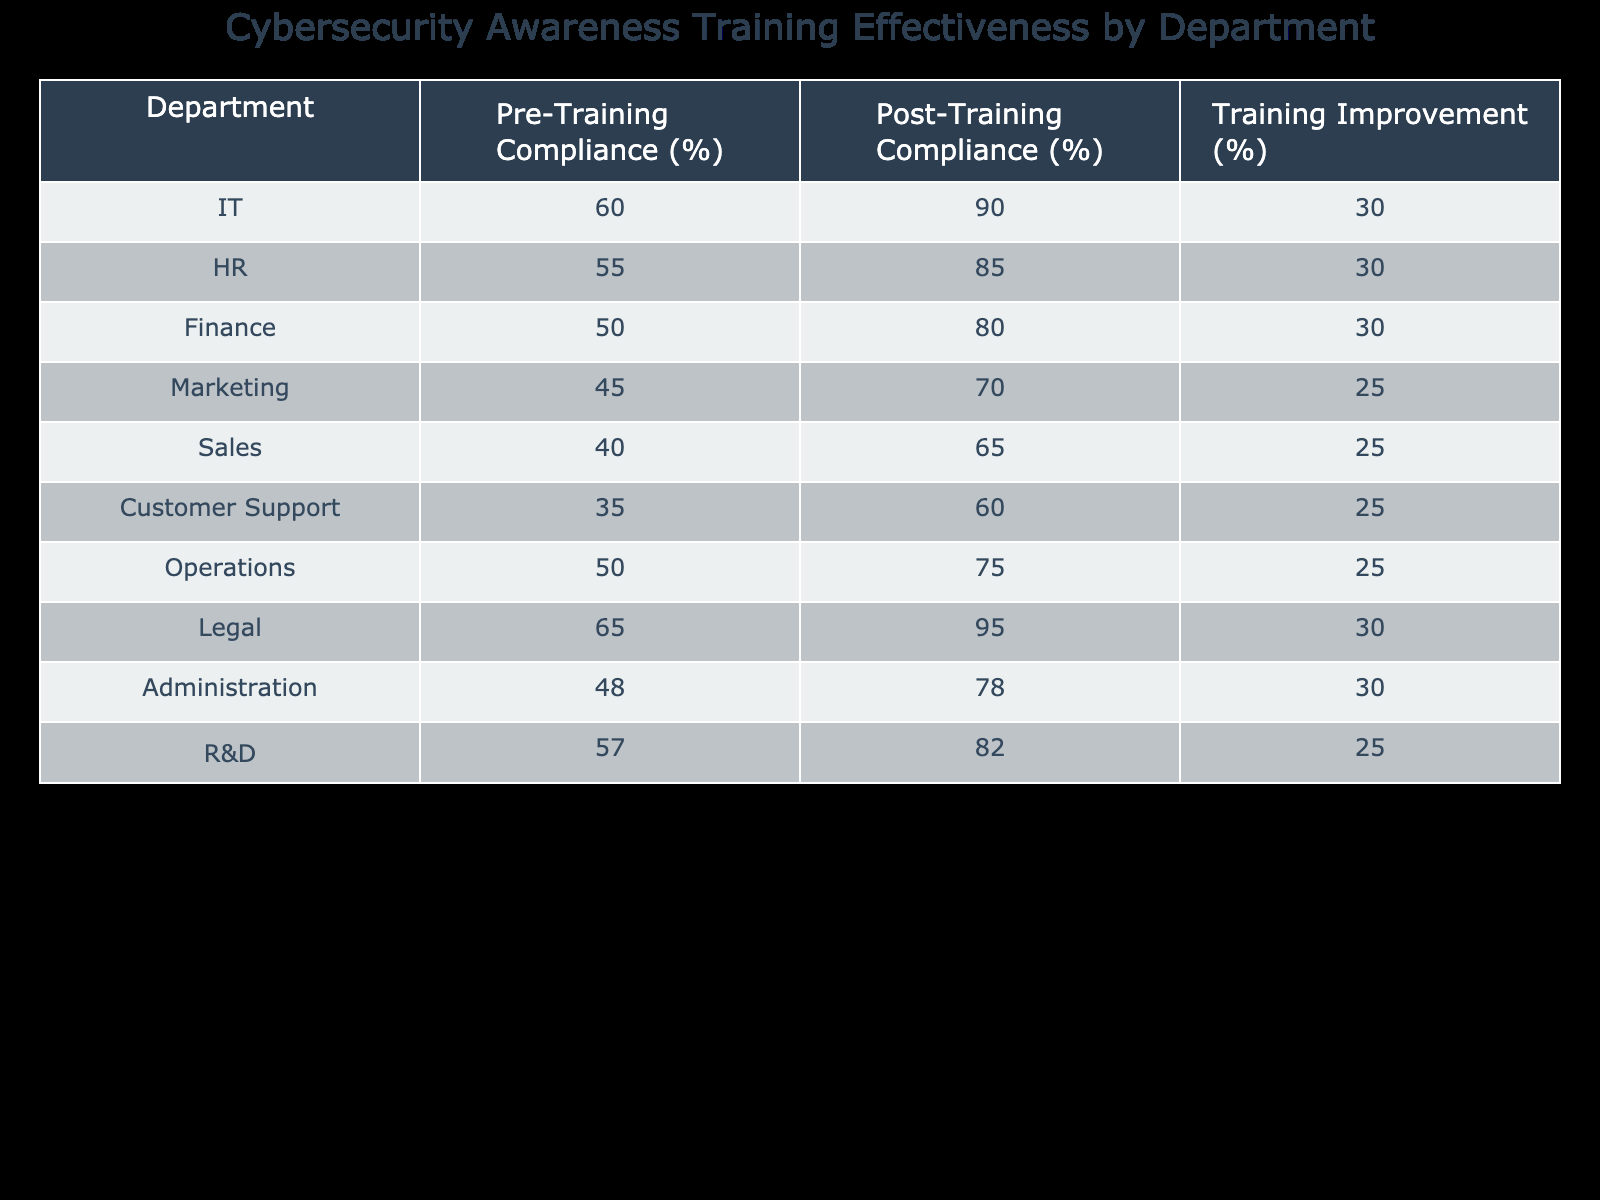What is the Pre-Training Compliance percentage for the IT department? The table shows that the Pre-Training Compliance percentage for the IT department is listed directly in the row for IT. Looking at that row, the value is 60%.
Answer: 60% What is the improvement in Compliance percentage for the HR department? The table indicates the Training Improvement percentage for the HR department. In the corresponding row, it states that the improvement is 30%.
Answer: 30% Which department had the highest Post-Training Compliance percentage? To find the highest Post-Training Compliance percentage, we check all the post-training compliance values in the table. The Legal department has the highest value at 95%.
Answer: Legal Is the average Training Improvement percentage across all departments greater than 28%? First, we total the Training Improvement percentages from each department. Adding (30 + 30 + 30 + 25 + 25 + 25 + 25 + 30 + 30 + 25) gives a sum of  305. There are 10 departments, so the average is calculated as 305/10 = 30.5%, which is greater than 28%.
Answer: Yes Which department showed the least improvement in compliance percentage? We need to review the Training Improvement percentages for all departments. The lowest value in this column is 25%, seen in the Marketing, Sales, Customer Support, and R&D departments. Thus, they all show the least improvement equally.
Answer: Marketing, Sales, Customer Support, R&D What was the total of the Pre-Training Compliance percentages for all departments? By summing the Pre-Training Compliance percentages from each department: (60 + 55 + 50 + 45 + 40 + 35 + 50 + 65 + 48 + 57) results in 455. This indicates the combined compliance before training.
Answer: 455 Is the Post-Training Compliance percentage for the Finance department higher than 80%? The table shows that the Post-Training Compliance percentage for the Finance department is 80%. Since it is not greater than 80%, the answer is no.
Answer: No What is the difference between the highest and lowest Pre-Training Compliance percentages among the listed departments? The highest Pre-Training Compliance percentage is 65% (Legal department) and the lowest is 35% (Customer Support department). The difference is calculated as 65 - 35 = 30%.
Answer: 30% 